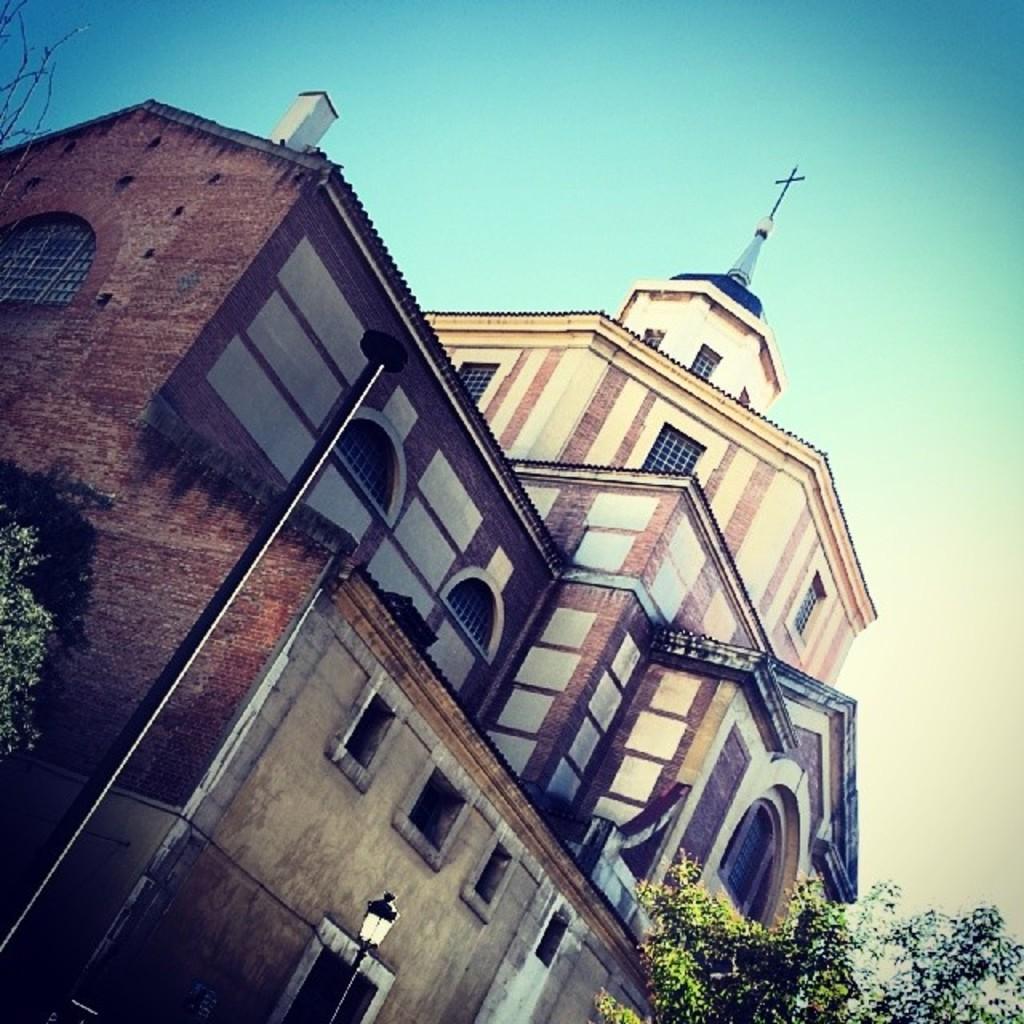Could you give a brief overview of what you see in this image? In this image I can see the building , in front of the building I can see the tree and street light pole and at the I can see the sky. 